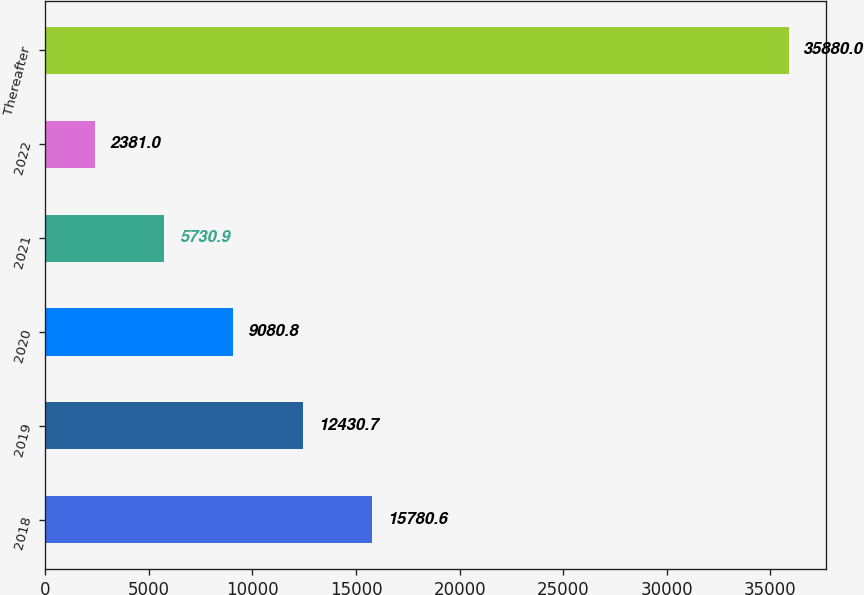Convert chart. <chart><loc_0><loc_0><loc_500><loc_500><bar_chart><fcel>2018<fcel>2019<fcel>2020<fcel>2021<fcel>2022<fcel>Thereafter<nl><fcel>15780.6<fcel>12430.7<fcel>9080.8<fcel>5730.9<fcel>2381<fcel>35880<nl></chart> 